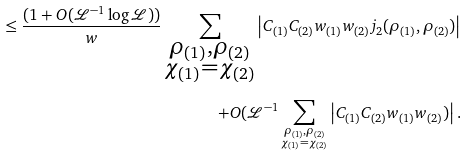Convert formula to latex. <formula><loc_0><loc_0><loc_500><loc_500>\leq \frac { ( 1 + O ( \mathcal { L } ^ { - 1 } \log { \mathcal { L } } ) ) } { w } \sum _ { \substack { \rho _ { ( 1 ) } , \rho _ { ( 2 ) } \\ \chi _ { ( 1 ) } = \chi _ { ( 2 ) } } } \left | C _ { ( 1 ) } C _ { ( 2 ) } w _ { ( 1 ) } w _ { ( 2 ) } j _ { 2 } ( \rho _ { ( 1 ) } , \rho _ { ( 2 ) } ) \right | \\ + O ( \mathcal { L } ^ { - 1 } \sum _ { \substack { \rho _ { ( 1 ) } , \rho _ { ( 2 ) } \\ \chi _ { ( 1 ) } = \chi _ { ( 2 ) } } } \left | C _ { ( 1 ) } C _ { ( 2 ) } w _ { ( 1 ) } w _ { ( 2 ) } ) \right | .</formula> 